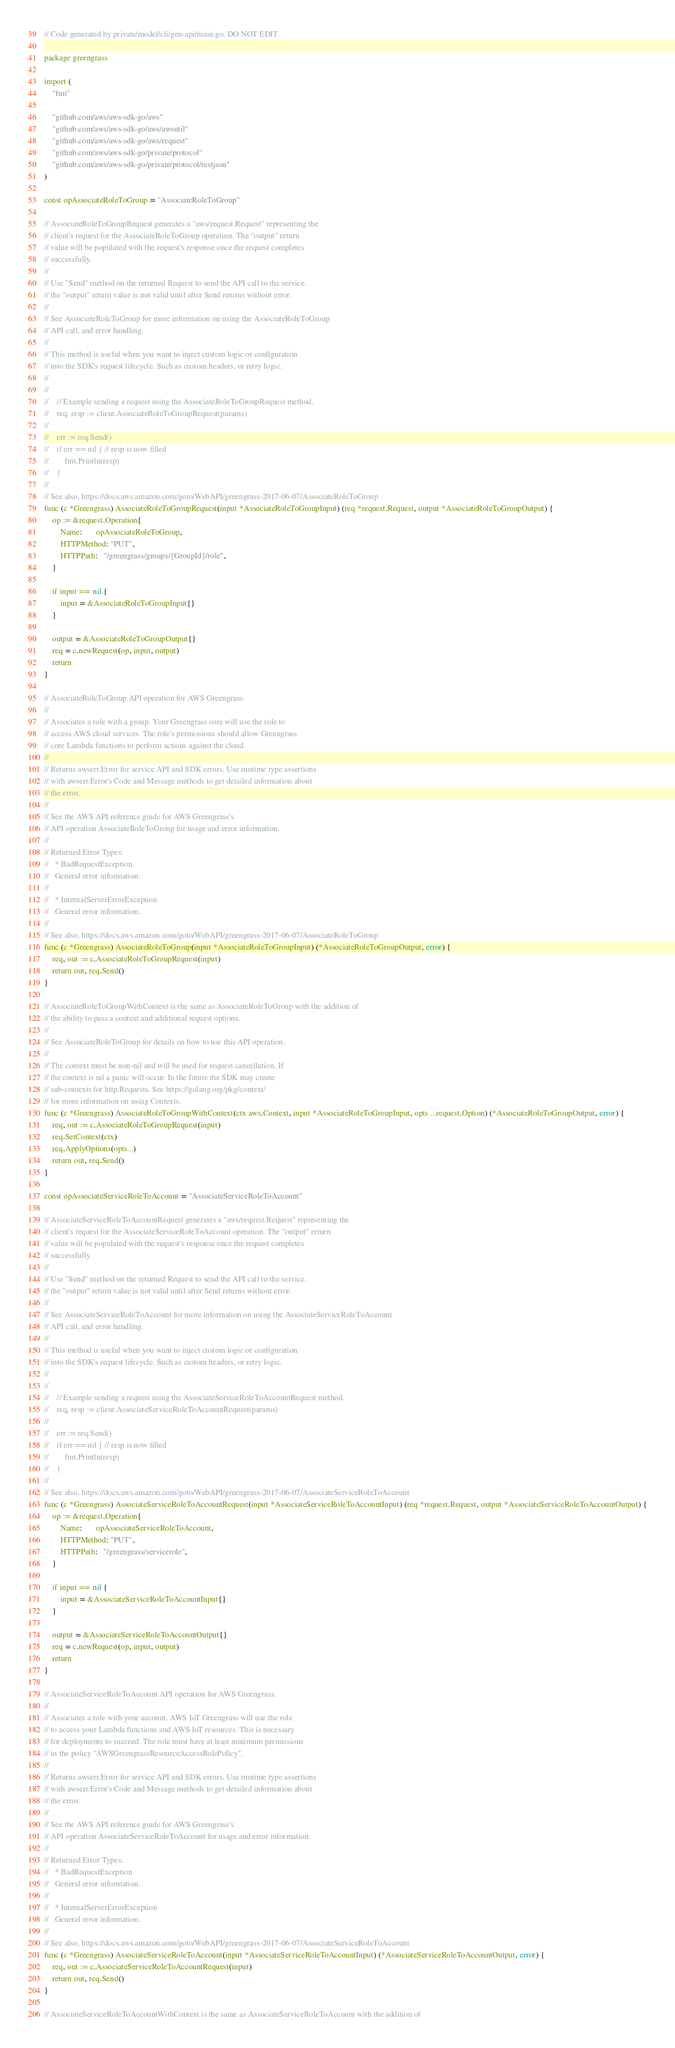<code> <loc_0><loc_0><loc_500><loc_500><_Go_>// Code generated by private/model/cli/gen-api/main.go. DO NOT EDIT.

package greengrass

import (
	"fmt"

	"github.com/aws/aws-sdk-go/aws"
	"github.com/aws/aws-sdk-go/aws/awsutil"
	"github.com/aws/aws-sdk-go/aws/request"
	"github.com/aws/aws-sdk-go/private/protocol"
	"github.com/aws/aws-sdk-go/private/protocol/restjson"
)

const opAssociateRoleToGroup = "AssociateRoleToGroup"

// AssociateRoleToGroupRequest generates a "aws/request.Request" representing the
// client's request for the AssociateRoleToGroup operation. The "output" return
// value will be populated with the request's response once the request completes
// successfully.
//
// Use "Send" method on the returned Request to send the API call to the service.
// the "output" return value is not valid until after Send returns without error.
//
// See AssociateRoleToGroup for more information on using the AssociateRoleToGroup
// API call, and error handling.
//
// This method is useful when you want to inject custom logic or configuration
// into the SDK's request lifecycle. Such as custom headers, or retry logic.
//
//
//    // Example sending a request using the AssociateRoleToGroupRequest method.
//    req, resp := client.AssociateRoleToGroupRequest(params)
//
//    err := req.Send()
//    if err == nil { // resp is now filled
//        fmt.Println(resp)
//    }
//
// See also, https://docs.aws.amazon.com/goto/WebAPI/greengrass-2017-06-07/AssociateRoleToGroup
func (c *Greengrass) AssociateRoleToGroupRequest(input *AssociateRoleToGroupInput) (req *request.Request, output *AssociateRoleToGroupOutput) {
	op := &request.Operation{
		Name:       opAssociateRoleToGroup,
		HTTPMethod: "PUT",
		HTTPPath:   "/greengrass/groups/{GroupId}/role",
	}

	if input == nil {
		input = &AssociateRoleToGroupInput{}
	}

	output = &AssociateRoleToGroupOutput{}
	req = c.newRequest(op, input, output)
	return
}

// AssociateRoleToGroup API operation for AWS Greengrass.
//
// Associates a role with a group. Your Greengrass core will use the role to
// access AWS cloud services. The role's permissions should allow Greengrass
// core Lambda functions to perform actions against the cloud.
//
// Returns awserr.Error for service API and SDK errors. Use runtime type assertions
// with awserr.Error's Code and Message methods to get detailed information about
// the error.
//
// See the AWS API reference guide for AWS Greengrass's
// API operation AssociateRoleToGroup for usage and error information.
//
// Returned Error Types:
//   * BadRequestException
//   General error information.
//
//   * InternalServerErrorException
//   General error information.
//
// See also, https://docs.aws.amazon.com/goto/WebAPI/greengrass-2017-06-07/AssociateRoleToGroup
func (c *Greengrass) AssociateRoleToGroup(input *AssociateRoleToGroupInput) (*AssociateRoleToGroupOutput, error) {
	req, out := c.AssociateRoleToGroupRequest(input)
	return out, req.Send()
}

// AssociateRoleToGroupWithContext is the same as AssociateRoleToGroup with the addition of
// the ability to pass a context and additional request options.
//
// See AssociateRoleToGroup for details on how to use this API operation.
//
// The context must be non-nil and will be used for request cancellation. If
// the context is nil a panic will occur. In the future the SDK may create
// sub-contexts for http.Requests. See https://golang.org/pkg/context/
// for more information on using Contexts.
func (c *Greengrass) AssociateRoleToGroupWithContext(ctx aws.Context, input *AssociateRoleToGroupInput, opts ...request.Option) (*AssociateRoleToGroupOutput, error) {
	req, out := c.AssociateRoleToGroupRequest(input)
	req.SetContext(ctx)
	req.ApplyOptions(opts...)
	return out, req.Send()
}

const opAssociateServiceRoleToAccount = "AssociateServiceRoleToAccount"

// AssociateServiceRoleToAccountRequest generates a "aws/request.Request" representing the
// client's request for the AssociateServiceRoleToAccount operation. The "output" return
// value will be populated with the request's response once the request completes
// successfully.
//
// Use "Send" method on the returned Request to send the API call to the service.
// the "output" return value is not valid until after Send returns without error.
//
// See AssociateServiceRoleToAccount for more information on using the AssociateServiceRoleToAccount
// API call, and error handling.
//
// This method is useful when you want to inject custom logic or configuration
// into the SDK's request lifecycle. Such as custom headers, or retry logic.
//
//
//    // Example sending a request using the AssociateServiceRoleToAccountRequest method.
//    req, resp := client.AssociateServiceRoleToAccountRequest(params)
//
//    err := req.Send()
//    if err == nil { // resp is now filled
//        fmt.Println(resp)
//    }
//
// See also, https://docs.aws.amazon.com/goto/WebAPI/greengrass-2017-06-07/AssociateServiceRoleToAccount
func (c *Greengrass) AssociateServiceRoleToAccountRequest(input *AssociateServiceRoleToAccountInput) (req *request.Request, output *AssociateServiceRoleToAccountOutput) {
	op := &request.Operation{
		Name:       opAssociateServiceRoleToAccount,
		HTTPMethod: "PUT",
		HTTPPath:   "/greengrass/servicerole",
	}

	if input == nil {
		input = &AssociateServiceRoleToAccountInput{}
	}

	output = &AssociateServiceRoleToAccountOutput{}
	req = c.newRequest(op, input, output)
	return
}

// AssociateServiceRoleToAccount API operation for AWS Greengrass.
//
// Associates a role with your account. AWS IoT Greengrass will use the role
// to access your Lambda functions and AWS IoT resources. This is necessary
// for deployments to succeed. The role must have at least minimum permissions
// in the policy ''AWSGreengrassResourceAccessRolePolicy''.
//
// Returns awserr.Error for service API and SDK errors. Use runtime type assertions
// with awserr.Error's Code and Message methods to get detailed information about
// the error.
//
// See the AWS API reference guide for AWS Greengrass's
// API operation AssociateServiceRoleToAccount for usage and error information.
//
// Returned Error Types:
//   * BadRequestException
//   General error information.
//
//   * InternalServerErrorException
//   General error information.
//
// See also, https://docs.aws.amazon.com/goto/WebAPI/greengrass-2017-06-07/AssociateServiceRoleToAccount
func (c *Greengrass) AssociateServiceRoleToAccount(input *AssociateServiceRoleToAccountInput) (*AssociateServiceRoleToAccountOutput, error) {
	req, out := c.AssociateServiceRoleToAccountRequest(input)
	return out, req.Send()
}

// AssociateServiceRoleToAccountWithContext is the same as AssociateServiceRoleToAccount with the addition of</code> 